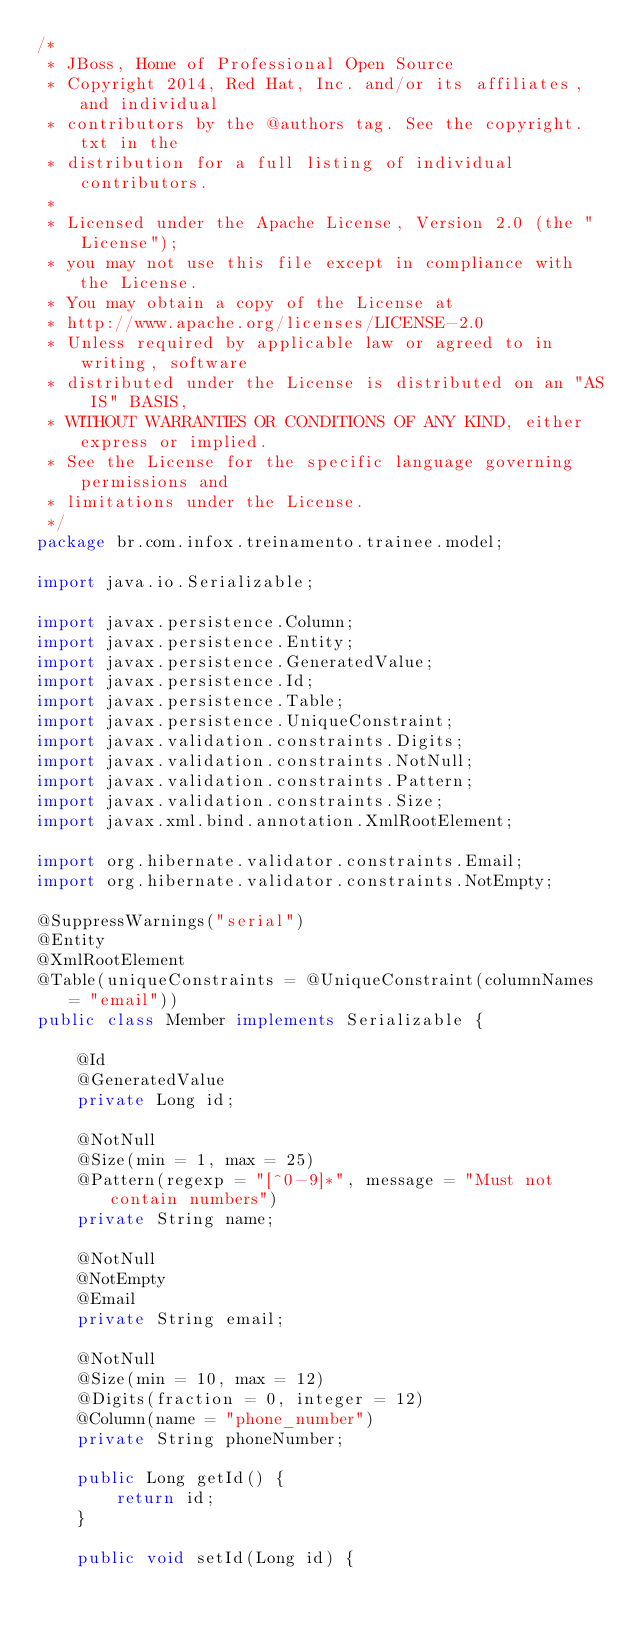Convert code to text. <code><loc_0><loc_0><loc_500><loc_500><_Java_>/*
 * JBoss, Home of Professional Open Source
 * Copyright 2014, Red Hat, Inc. and/or its affiliates, and individual
 * contributors by the @authors tag. See the copyright.txt in the
 * distribution for a full listing of individual contributors.
 *
 * Licensed under the Apache License, Version 2.0 (the "License");
 * you may not use this file except in compliance with the License.
 * You may obtain a copy of the License at
 * http://www.apache.org/licenses/LICENSE-2.0
 * Unless required by applicable law or agreed to in writing, software
 * distributed under the License is distributed on an "AS IS" BASIS,
 * WITHOUT WARRANTIES OR CONDITIONS OF ANY KIND, either express or implied.
 * See the License for the specific language governing permissions and
 * limitations under the License.
 */
package br.com.infox.treinamento.trainee.model;

import java.io.Serializable;

import javax.persistence.Column;
import javax.persistence.Entity;
import javax.persistence.GeneratedValue;
import javax.persistence.Id;
import javax.persistence.Table;
import javax.persistence.UniqueConstraint;
import javax.validation.constraints.Digits;
import javax.validation.constraints.NotNull;
import javax.validation.constraints.Pattern;
import javax.validation.constraints.Size;
import javax.xml.bind.annotation.XmlRootElement;

import org.hibernate.validator.constraints.Email;
import org.hibernate.validator.constraints.NotEmpty;

@SuppressWarnings("serial")
@Entity
@XmlRootElement
@Table(uniqueConstraints = @UniqueConstraint(columnNames = "email"))
public class Member implements Serializable {

    @Id
    @GeneratedValue
    private Long id;

    @NotNull
    @Size(min = 1, max = 25)
    @Pattern(regexp = "[^0-9]*", message = "Must not contain numbers")
    private String name;

    @NotNull
    @NotEmpty
    @Email
    private String email;

    @NotNull
    @Size(min = 10, max = 12)
    @Digits(fraction = 0, integer = 12)
    @Column(name = "phone_number")
    private String phoneNumber;

    public Long getId() {
        return id;
    }

    public void setId(Long id) {</code> 